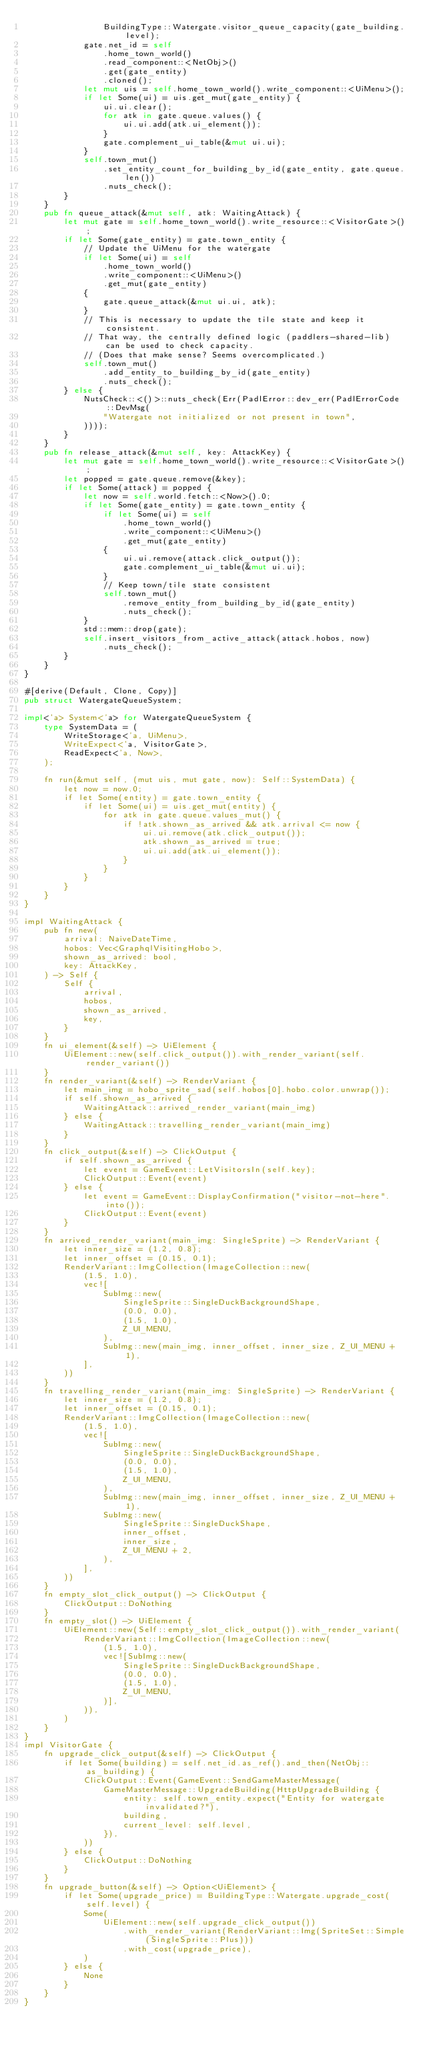Convert code to text. <code><loc_0><loc_0><loc_500><loc_500><_Rust_>                BuildingType::Watergate.visitor_queue_capacity(gate_building.level);
            gate.net_id = self
                .home_town_world()
                .read_component::<NetObj>()
                .get(gate_entity)
                .cloned();
            let mut uis = self.home_town_world().write_component::<UiMenu>();
            if let Some(ui) = uis.get_mut(gate_entity) {
                ui.ui.clear();
                for atk in gate.queue.values() {
                    ui.ui.add(atk.ui_element());
                }
                gate.complement_ui_table(&mut ui.ui);
            }
            self.town_mut()
                .set_entity_count_for_building_by_id(gate_entity, gate.queue.len())
                .nuts_check();
        }
    }
    pub fn queue_attack(&mut self, atk: WaitingAttack) {
        let mut gate = self.home_town_world().write_resource::<VisitorGate>();
        if let Some(gate_entity) = gate.town_entity {
            // Update the UiMenu for the watergate
            if let Some(ui) = self
                .home_town_world()
                .write_component::<UiMenu>()
                .get_mut(gate_entity)
            {
                gate.queue_attack(&mut ui.ui, atk);
            }
            // This is necessary to update the tile state and keep it consistent.
            // That way, the centrally defined logic (paddlers-shared-lib) can be used to check capacity.
            // (Does that make sense? Seems overcomplicated.)
            self.town_mut()
                .add_entity_to_building_by_id(gate_entity)
                .nuts_check();
        } else {
            NutsCheck::<()>::nuts_check(Err(PadlError::dev_err(PadlErrorCode::DevMsg(
                "Watergate not initialized or not present in town",
            ))));
        }
    }
    pub fn release_attack(&mut self, key: AttackKey) {
        let mut gate = self.home_town_world().write_resource::<VisitorGate>();
        let popped = gate.queue.remove(&key);
        if let Some(attack) = popped {
            let now = self.world.fetch::<Now>().0;
            if let Some(gate_entity) = gate.town_entity {
                if let Some(ui) = self
                    .home_town_world()
                    .write_component::<UiMenu>()
                    .get_mut(gate_entity)
                {
                    ui.ui.remove(attack.click_output());
                    gate.complement_ui_table(&mut ui.ui);
                }
                // Keep town/tile state consistent
                self.town_mut()
                    .remove_entity_from_building_by_id(gate_entity)
                    .nuts_check();
            }
            std::mem::drop(gate);
            self.insert_visitors_from_active_attack(attack.hobos, now)
                .nuts_check();
        }
    }
}

#[derive(Default, Clone, Copy)]
pub struct WatergateQueueSystem;

impl<'a> System<'a> for WatergateQueueSystem {
    type SystemData = (
        WriteStorage<'a, UiMenu>,
        WriteExpect<'a, VisitorGate>,
        ReadExpect<'a, Now>,
    );

    fn run(&mut self, (mut uis, mut gate, now): Self::SystemData) {
        let now = now.0;
        if let Some(entity) = gate.town_entity {
            if let Some(ui) = uis.get_mut(entity) {
                for atk in gate.queue.values_mut() {
                    if !atk.shown_as_arrived && atk.arrival <= now {
                        ui.ui.remove(atk.click_output());
                        atk.shown_as_arrived = true;
                        ui.ui.add(atk.ui_element());
                    }
                }
            }
        }
    }
}

impl WaitingAttack {
    pub fn new(
        arrival: NaiveDateTime,
        hobos: Vec<GraphqlVisitingHobo>,
        shown_as_arrived: bool,
        key: AttackKey,
    ) -> Self {
        Self {
            arrival,
            hobos,
            shown_as_arrived,
            key,
        }
    }
    fn ui_element(&self) -> UiElement {
        UiElement::new(self.click_output()).with_render_variant(self.render_variant())
    }
    fn render_variant(&self) -> RenderVariant {
        let main_img = hobo_sprite_sad(self.hobos[0].hobo.color.unwrap());
        if self.shown_as_arrived {
            WaitingAttack::arrived_render_variant(main_img)
        } else {
            WaitingAttack::travelling_render_variant(main_img)
        }
    }
    fn click_output(&self) -> ClickOutput {
        if self.shown_as_arrived {
            let event = GameEvent::LetVisitorsIn(self.key);
            ClickOutput::Event(event)
        } else {
            let event = GameEvent::DisplayConfirmation("visitor-not-here".into());
            ClickOutput::Event(event)
        }
    }
    fn arrived_render_variant(main_img: SingleSprite) -> RenderVariant {
        let inner_size = (1.2, 0.8);
        let inner_offset = (0.15, 0.1);
        RenderVariant::ImgCollection(ImageCollection::new(
            (1.5, 1.0),
            vec![
                SubImg::new(
                    SingleSprite::SingleDuckBackgroundShape,
                    (0.0, 0.0),
                    (1.5, 1.0),
                    Z_UI_MENU,
                ),
                SubImg::new(main_img, inner_offset, inner_size, Z_UI_MENU + 1),
            ],
        ))
    }
    fn travelling_render_variant(main_img: SingleSprite) -> RenderVariant {
        let inner_size = (1.2, 0.8);
        let inner_offset = (0.15, 0.1);
        RenderVariant::ImgCollection(ImageCollection::new(
            (1.5, 1.0),
            vec![
                SubImg::new(
                    SingleSprite::SingleDuckBackgroundShape,
                    (0.0, 0.0),
                    (1.5, 1.0),
                    Z_UI_MENU,
                ),
                SubImg::new(main_img, inner_offset, inner_size, Z_UI_MENU + 1),
                SubImg::new(
                    SingleSprite::SingleDuckShape,
                    inner_offset,
                    inner_size,
                    Z_UI_MENU + 2,
                ),
            ],
        ))
    }
    fn empty_slot_click_output() -> ClickOutput {
        ClickOutput::DoNothing
    }
    fn empty_slot() -> UiElement {
        UiElement::new(Self::empty_slot_click_output()).with_render_variant(
            RenderVariant::ImgCollection(ImageCollection::new(
                (1.5, 1.0),
                vec![SubImg::new(
                    SingleSprite::SingleDuckBackgroundShape,
                    (0.0, 0.0),
                    (1.5, 1.0),
                    Z_UI_MENU,
                )],
            )),
        )
    }
}
impl VisitorGate {
    fn upgrade_click_output(&self) -> ClickOutput {
        if let Some(building) = self.net_id.as_ref().and_then(NetObj::as_building) {
            ClickOutput::Event(GameEvent::SendGameMasterMessage(
                GameMasterMessage::UpgradeBuilding(HttpUpgradeBuilding {
                    entity: self.town_entity.expect("Entity for watergate invalidated?"),
                    building,
                    current_level: self.level,
                }),
            ))
        } else {
            ClickOutput::DoNothing
        }
    }
    fn upgrade_button(&self) -> Option<UiElement> {
        if let Some(upgrade_price) = BuildingType::Watergate.upgrade_cost(self.level) {
            Some(
                UiElement::new(self.upgrade_click_output())
                    .with_render_variant(RenderVariant::Img(SpriteSet::Simple(SingleSprite::Plus)))
                    .with_cost(upgrade_price),
            )
        } else {
            None
        }
    }
}
</code> 